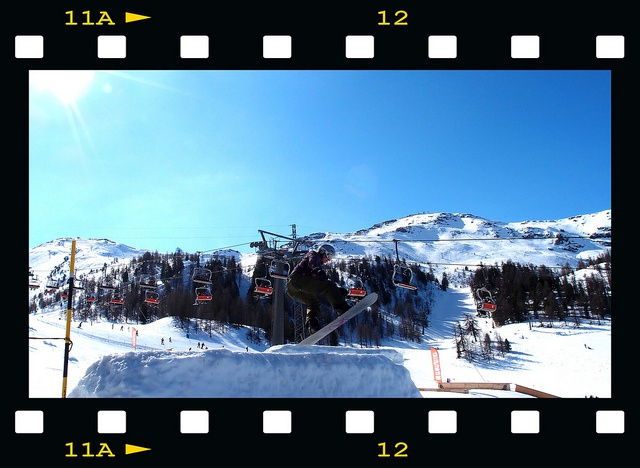Describe the objects in this image and their specific colors. I can see people in black, gray, navy, and darkgray tones, snowboard in black, gray, and darkblue tones, bench in black, gray, maroon, and brown tones, bench in black, brown, gray, and maroon tones, and bench in black, brown, maroon, and gray tones in this image. 